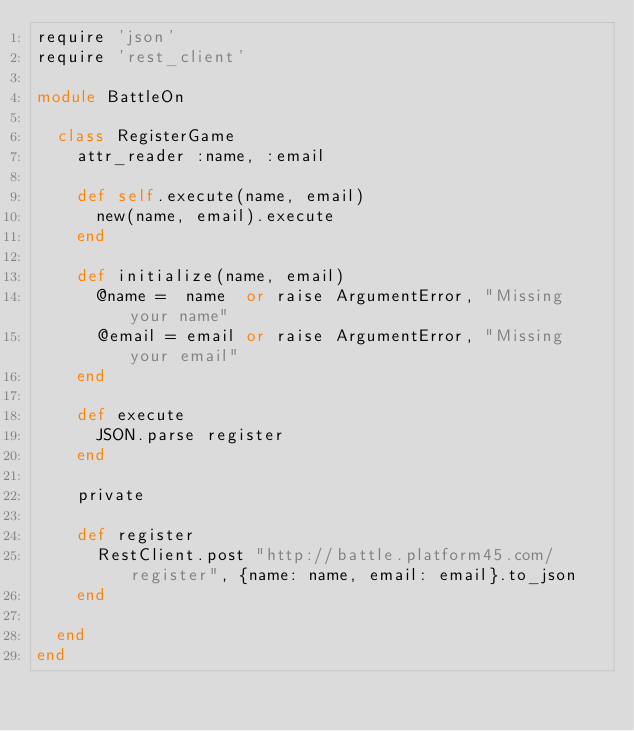<code> <loc_0><loc_0><loc_500><loc_500><_Ruby_>require 'json'
require 'rest_client'

module BattleOn

  class RegisterGame
    attr_reader :name, :email

    def self.execute(name, email)
      new(name, email).execute
    end

    def initialize(name, email)
      @name =  name  or raise ArgumentError, "Missing your name"
      @email = email or raise ArgumentError, "Missing your email"
    end

    def execute
      JSON.parse register
    end

    private

    def register
      RestClient.post "http://battle.platform45.com/register", {name: name, email: email}.to_json
    end

  end
end
</code> 